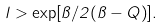<formula> <loc_0><loc_0><loc_500><loc_500>l > \exp [ { \pi } / { 2 ( \pi - Q ) } ] .</formula> 